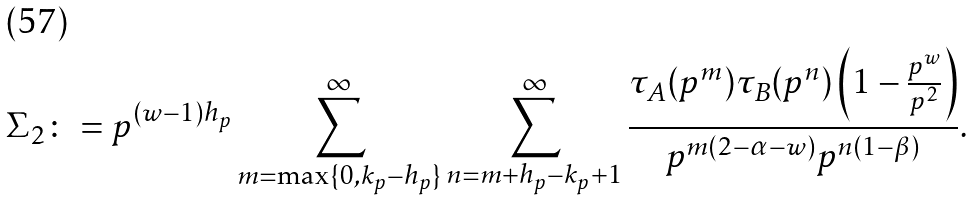<formula> <loc_0><loc_0><loc_500><loc_500>\Sigma _ { 2 } \colon = p ^ { ( w - 1 ) h _ { p } } \sum _ { m = \max \{ 0 , k _ { p } - h _ { p } \} } ^ { \infty } \sum _ { n = m + h _ { p } - k _ { p } + 1 } ^ { \infty } \frac { \tau _ { A } ( p ^ { m } ) \tau _ { B } ( p ^ { n } ) \left ( 1 - \frac { p ^ { w } } { p ^ { 2 } } \right ) } { p ^ { m ( 2 - \alpha - w ) } p ^ { n ( 1 - \beta ) } } .</formula> 